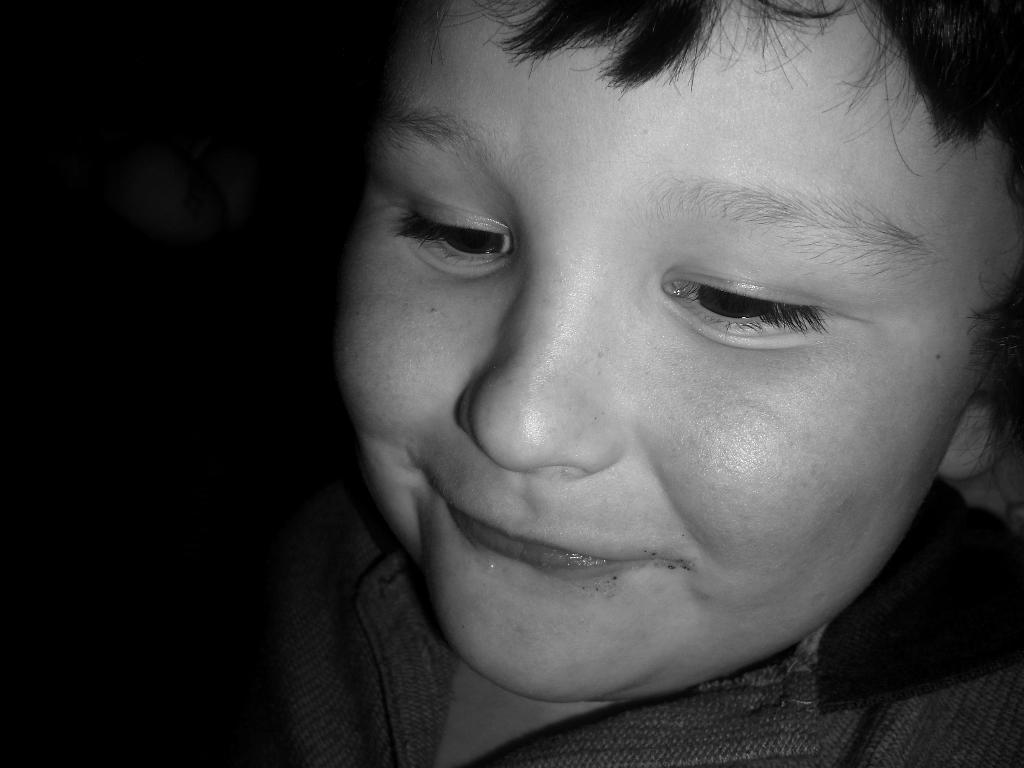Describe this image in one or two sentences. In this image we can see a boy smiling. 